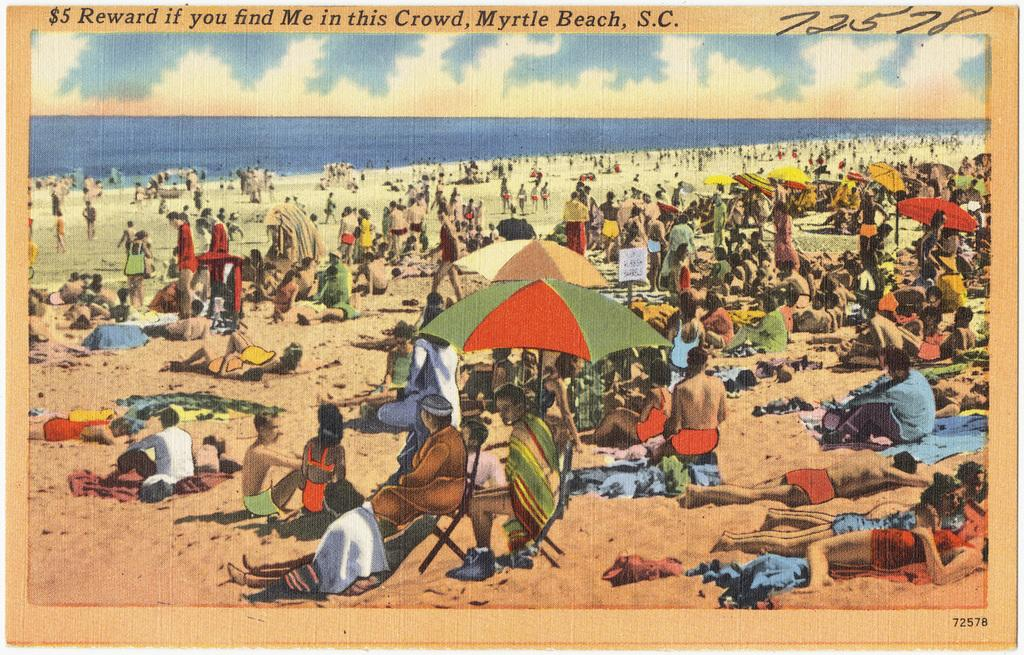<image>
Provide a brief description of the given image. Postcard that shows people at the beach and the words "Myrtle Beach" on top. 